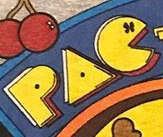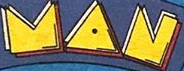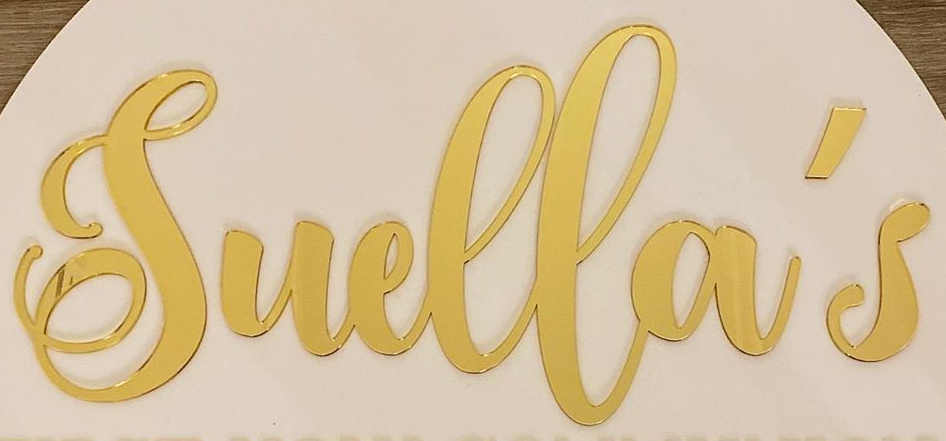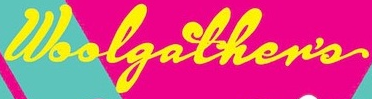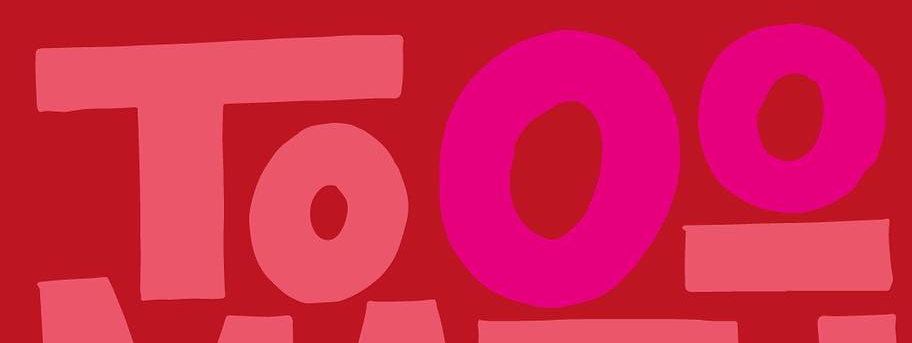What words are shown in these images in order, separated by a semicolon? PAC; MAN; Suella's; Woolgather's; Tooo 